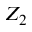<formula> <loc_0><loc_0><loc_500><loc_500>Z _ { 2 }</formula> 